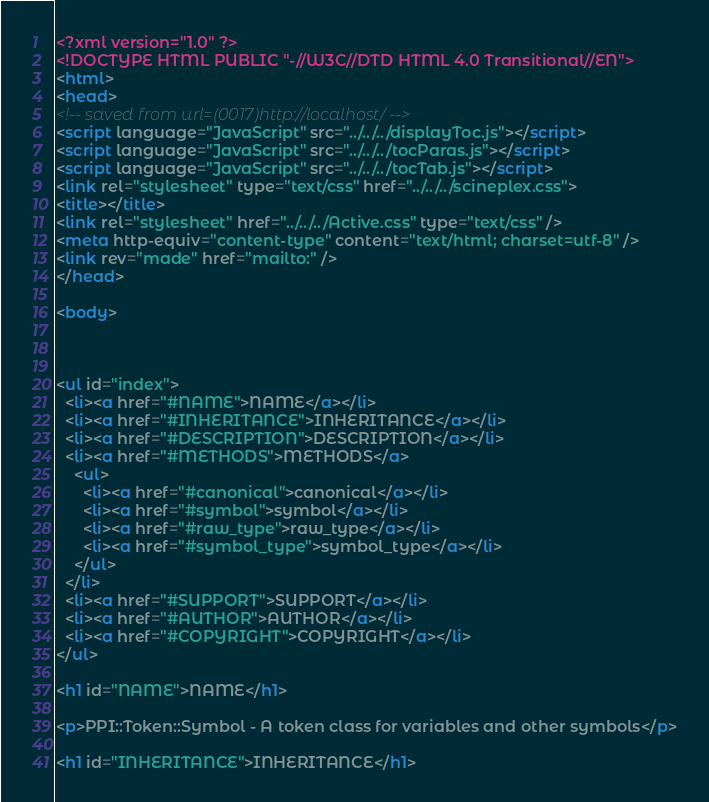Convert code to text. <code><loc_0><loc_0><loc_500><loc_500><_HTML_><?xml version="1.0" ?>
<!DOCTYPE HTML PUBLIC "-//W3C//DTD HTML 4.0 Transitional//EN">
<html>
<head>
<!-- saved from url=(0017)http://localhost/ -->
<script language="JavaScript" src="../../../displayToc.js"></script>
<script language="JavaScript" src="../../../tocParas.js"></script>
<script language="JavaScript" src="../../../tocTab.js"></script>
<link rel="stylesheet" type="text/css" href="../../../scineplex.css">
<title></title>
<link rel="stylesheet" href="../../../Active.css" type="text/css" />
<meta http-equiv="content-type" content="text/html; charset=utf-8" />
<link rev="made" href="mailto:" />
</head>

<body>



<ul id="index">
  <li><a href="#NAME">NAME</a></li>
  <li><a href="#INHERITANCE">INHERITANCE</a></li>
  <li><a href="#DESCRIPTION">DESCRIPTION</a></li>
  <li><a href="#METHODS">METHODS</a>
    <ul>
      <li><a href="#canonical">canonical</a></li>
      <li><a href="#symbol">symbol</a></li>
      <li><a href="#raw_type">raw_type</a></li>
      <li><a href="#symbol_type">symbol_type</a></li>
    </ul>
  </li>
  <li><a href="#SUPPORT">SUPPORT</a></li>
  <li><a href="#AUTHOR">AUTHOR</a></li>
  <li><a href="#COPYRIGHT">COPYRIGHT</a></li>
</ul>

<h1 id="NAME">NAME</h1>

<p>PPI::Token::Symbol - A token class for variables and other symbols</p>

<h1 id="INHERITANCE">INHERITANCE</h1>
</code> 